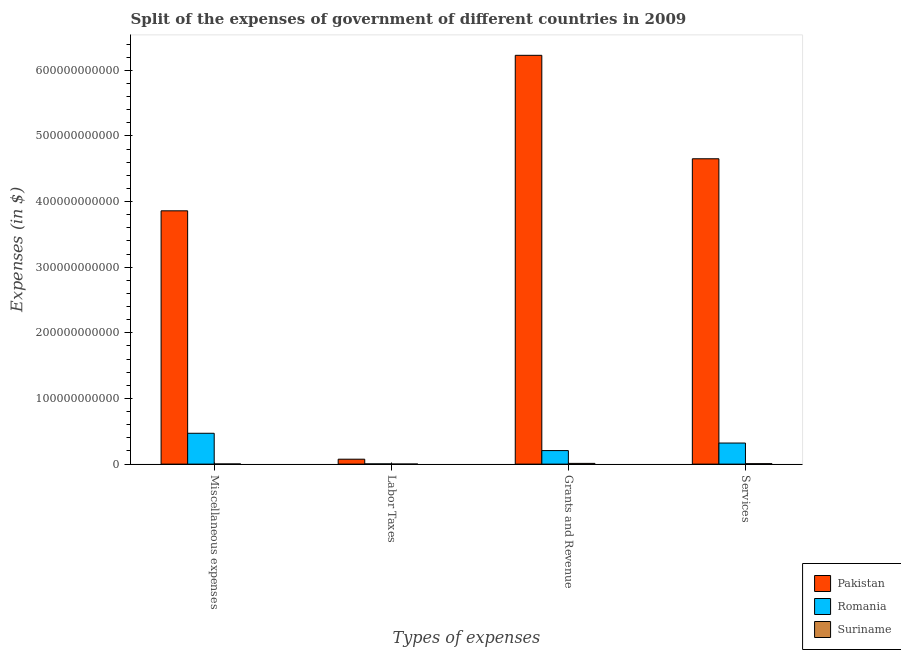How many different coloured bars are there?
Your answer should be very brief. 3. How many groups of bars are there?
Offer a terse response. 4. Are the number of bars on each tick of the X-axis equal?
Ensure brevity in your answer.  Yes. How many bars are there on the 4th tick from the left?
Provide a succinct answer. 3. How many bars are there on the 4th tick from the right?
Your response must be concise. 3. What is the label of the 1st group of bars from the left?
Make the answer very short. Miscellaneous expenses. What is the amount spent on miscellaneous expenses in Romania?
Give a very brief answer. 4.70e+1. Across all countries, what is the maximum amount spent on services?
Offer a terse response. 4.65e+11. Across all countries, what is the minimum amount spent on miscellaneous expenses?
Provide a succinct answer. 2.15e+08. In which country was the amount spent on labor taxes minimum?
Your answer should be compact. Suriname. What is the total amount spent on miscellaneous expenses in the graph?
Your response must be concise. 4.33e+11. What is the difference between the amount spent on services in Pakistan and that in Romania?
Offer a very short reply. 4.33e+11. What is the difference between the amount spent on labor taxes in Romania and the amount spent on miscellaneous expenses in Suriname?
Ensure brevity in your answer.  1.26e+08. What is the average amount spent on labor taxes per country?
Offer a terse response. 2.64e+09. What is the difference between the amount spent on labor taxes and amount spent on miscellaneous expenses in Suriname?
Your response must be concise. -1.29e+08. In how many countries, is the amount spent on services greater than 420000000000 $?
Make the answer very short. 1. What is the ratio of the amount spent on labor taxes in Pakistan to that in Suriname?
Provide a succinct answer. 87.54. Is the amount spent on labor taxes in Suriname less than that in Romania?
Provide a succinct answer. Yes. What is the difference between the highest and the second highest amount spent on labor taxes?
Offer a very short reply. 7.16e+09. What is the difference between the highest and the lowest amount spent on grants and revenue?
Your answer should be very brief. 6.22e+11. Is the sum of the amount spent on services in Suriname and Pakistan greater than the maximum amount spent on labor taxes across all countries?
Offer a terse response. Yes. Is it the case that in every country, the sum of the amount spent on miscellaneous expenses and amount spent on grants and revenue is greater than the sum of amount spent on labor taxes and amount spent on services?
Your answer should be compact. No. What does the 2nd bar from the left in Labor Taxes represents?
Your answer should be very brief. Romania. What does the 2nd bar from the right in Grants and Revenue represents?
Offer a very short reply. Romania. How many bars are there?
Your response must be concise. 12. Are all the bars in the graph horizontal?
Offer a very short reply. No. What is the difference between two consecutive major ticks on the Y-axis?
Give a very brief answer. 1.00e+11. Are the values on the major ticks of Y-axis written in scientific E-notation?
Offer a terse response. No. Does the graph contain any zero values?
Keep it short and to the point. No. What is the title of the graph?
Ensure brevity in your answer.  Split of the expenses of government of different countries in 2009. Does "Niger" appear as one of the legend labels in the graph?
Ensure brevity in your answer.  No. What is the label or title of the X-axis?
Make the answer very short. Types of expenses. What is the label or title of the Y-axis?
Provide a succinct answer. Expenses (in $). What is the Expenses (in $) of Pakistan in Miscellaneous expenses?
Provide a short and direct response. 3.86e+11. What is the Expenses (in $) in Romania in Miscellaneous expenses?
Make the answer very short. 4.70e+1. What is the Expenses (in $) in Suriname in Miscellaneous expenses?
Provide a succinct answer. 2.15e+08. What is the Expenses (in $) of Pakistan in Labor Taxes?
Make the answer very short. 7.50e+09. What is the Expenses (in $) of Romania in Labor Taxes?
Give a very brief answer. 3.41e+08. What is the Expenses (in $) in Suriname in Labor Taxes?
Keep it short and to the point. 8.57e+07. What is the Expenses (in $) of Pakistan in Grants and Revenue?
Make the answer very short. 6.23e+11. What is the Expenses (in $) of Romania in Grants and Revenue?
Your answer should be compact. 2.06e+1. What is the Expenses (in $) in Suriname in Grants and Revenue?
Keep it short and to the point. 1.11e+09. What is the Expenses (in $) of Pakistan in Services?
Keep it short and to the point. 4.65e+11. What is the Expenses (in $) in Romania in Services?
Give a very brief answer. 3.21e+1. What is the Expenses (in $) of Suriname in Services?
Your answer should be compact. 6.52e+08. Across all Types of expenses, what is the maximum Expenses (in $) of Pakistan?
Offer a terse response. 6.23e+11. Across all Types of expenses, what is the maximum Expenses (in $) of Romania?
Make the answer very short. 4.70e+1. Across all Types of expenses, what is the maximum Expenses (in $) of Suriname?
Your answer should be very brief. 1.11e+09. Across all Types of expenses, what is the minimum Expenses (in $) of Pakistan?
Your answer should be compact. 7.50e+09. Across all Types of expenses, what is the minimum Expenses (in $) in Romania?
Make the answer very short. 3.41e+08. Across all Types of expenses, what is the minimum Expenses (in $) of Suriname?
Your answer should be compact. 8.57e+07. What is the total Expenses (in $) of Pakistan in the graph?
Provide a short and direct response. 1.48e+12. What is the total Expenses (in $) of Romania in the graph?
Offer a very short reply. 1.00e+11. What is the total Expenses (in $) in Suriname in the graph?
Your answer should be compact. 2.07e+09. What is the difference between the Expenses (in $) in Pakistan in Miscellaneous expenses and that in Labor Taxes?
Ensure brevity in your answer.  3.78e+11. What is the difference between the Expenses (in $) in Romania in Miscellaneous expenses and that in Labor Taxes?
Offer a very short reply. 4.66e+1. What is the difference between the Expenses (in $) of Suriname in Miscellaneous expenses and that in Labor Taxes?
Your response must be concise. 1.29e+08. What is the difference between the Expenses (in $) of Pakistan in Miscellaneous expenses and that in Grants and Revenue?
Ensure brevity in your answer.  -2.37e+11. What is the difference between the Expenses (in $) of Romania in Miscellaneous expenses and that in Grants and Revenue?
Keep it short and to the point. 2.64e+1. What is the difference between the Expenses (in $) in Suriname in Miscellaneous expenses and that in Grants and Revenue?
Provide a short and direct response. -8.98e+08. What is the difference between the Expenses (in $) in Pakistan in Miscellaneous expenses and that in Services?
Offer a terse response. -7.93e+1. What is the difference between the Expenses (in $) in Romania in Miscellaneous expenses and that in Services?
Provide a short and direct response. 1.49e+1. What is the difference between the Expenses (in $) of Suriname in Miscellaneous expenses and that in Services?
Keep it short and to the point. -4.37e+08. What is the difference between the Expenses (in $) of Pakistan in Labor Taxes and that in Grants and Revenue?
Offer a very short reply. -6.15e+11. What is the difference between the Expenses (in $) of Romania in Labor Taxes and that in Grants and Revenue?
Provide a succinct answer. -2.03e+1. What is the difference between the Expenses (in $) in Suriname in Labor Taxes and that in Grants and Revenue?
Provide a short and direct response. -1.03e+09. What is the difference between the Expenses (in $) of Pakistan in Labor Taxes and that in Services?
Your answer should be compact. -4.58e+11. What is the difference between the Expenses (in $) of Romania in Labor Taxes and that in Services?
Provide a succinct answer. -3.18e+1. What is the difference between the Expenses (in $) in Suriname in Labor Taxes and that in Services?
Provide a succinct answer. -5.67e+08. What is the difference between the Expenses (in $) in Pakistan in Grants and Revenue and that in Services?
Provide a succinct answer. 1.58e+11. What is the difference between the Expenses (in $) of Romania in Grants and Revenue and that in Services?
Offer a very short reply. -1.15e+1. What is the difference between the Expenses (in $) in Suriname in Grants and Revenue and that in Services?
Your answer should be compact. 4.61e+08. What is the difference between the Expenses (in $) of Pakistan in Miscellaneous expenses and the Expenses (in $) of Romania in Labor Taxes?
Your answer should be compact. 3.86e+11. What is the difference between the Expenses (in $) of Pakistan in Miscellaneous expenses and the Expenses (in $) of Suriname in Labor Taxes?
Your response must be concise. 3.86e+11. What is the difference between the Expenses (in $) in Romania in Miscellaneous expenses and the Expenses (in $) in Suriname in Labor Taxes?
Offer a terse response. 4.69e+1. What is the difference between the Expenses (in $) in Pakistan in Miscellaneous expenses and the Expenses (in $) in Romania in Grants and Revenue?
Make the answer very short. 3.65e+11. What is the difference between the Expenses (in $) in Pakistan in Miscellaneous expenses and the Expenses (in $) in Suriname in Grants and Revenue?
Keep it short and to the point. 3.85e+11. What is the difference between the Expenses (in $) in Romania in Miscellaneous expenses and the Expenses (in $) in Suriname in Grants and Revenue?
Your response must be concise. 4.59e+1. What is the difference between the Expenses (in $) in Pakistan in Miscellaneous expenses and the Expenses (in $) in Romania in Services?
Offer a terse response. 3.54e+11. What is the difference between the Expenses (in $) of Pakistan in Miscellaneous expenses and the Expenses (in $) of Suriname in Services?
Keep it short and to the point. 3.85e+11. What is the difference between the Expenses (in $) of Romania in Miscellaneous expenses and the Expenses (in $) of Suriname in Services?
Your answer should be very brief. 4.63e+1. What is the difference between the Expenses (in $) of Pakistan in Labor Taxes and the Expenses (in $) of Romania in Grants and Revenue?
Your response must be concise. -1.31e+1. What is the difference between the Expenses (in $) in Pakistan in Labor Taxes and the Expenses (in $) in Suriname in Grants and Revenue?
Give a very brief answer. 6.39e+09. What is the difference between the Expenses (in $) in Romania in Labor Taxes and the Expenses (in $) in Suriname in Grants and Revenue?
Provide a succinct answer. -7.72e+08. What is the difference between the Expenses (in $) in Pakistan in Labor Taxes and the Expenses (in $) in Romania in Services?
Provide a succinct answer. -2.46e+1. What is the difference between the Expenses (in $) in Pakistan in Labor Taxes and the Expenses (in $) in Suriname in Services?
Make the answer very short. 6.85e+09. What is the difference between the Expenses (in $) of Romania in Labor Taxes and the Expenses (in $) of Suriname in Services?
Your answer should be very brief. -3.11e+08. What is the difference between the Expenses (in $) in Pakistan in Grants and Revenue and the Expenses (in $) in Romania in Services?
Ensure brevity in your answer.  5.91e+11. What is the difference between the Expenses (in $) of Pakistan in Grants and Revenue and the Expenses (in $) of Suriname in Services?
Provide a succinct answer. 6.22e+11. What is the difference between the Expenses (in $) of Romania in Grants and Revenue and the Expenses (in $) of Suriname in Services?
Ensure brevity in your answer.  2.00e+1. What is the average Expenses (in $) in Pakistan per Types of expenses?
Provide a short and direct response. 3.70e+11. What is the average Expenses (in $) in Romania per Types of expenses?
Provide a succinct answer. 2.50e+1. What is the average Expenses (in $) of Suriname per Types of expenses?
Offer a terse response. 5.16e+08. What is the difference between the Expenses (in $) of Pakistan and Expenses (in $) of Romania in Miscellaneous expenses?
Offer a terse response. 3.39e+11. What is the difference between the Expenses (in $) in Pakistan and Expenses (in $) in Suriname in Miscellaneous expenses?
Your answer should be very brief. 3.86e+11. What is the difference between the Expenses (in $) of Romania and Expenses (in $) of Suriname in Miscellaneous expenses?
Ensure brevity in your answer.  4.68e+1. What is the difference between the Expenses (in $) of Pakistan and Expenses (in $) of Romania in Labor Taxes?
Your response must be concise. 7.16e+09. What is the difference between the Expenses (in $) of Pakistan and Expenses (in $) of Suriname in Labor Taxes?
Your response must be concise. 7.42e+09. What is the difference between the Expenses (in $) of Romania and Expenses (in $) of Suriname in Labor Taxes?
Provide a succinct answer. 2.55e+08. What is the difference between the Expenses (in $) of Pakistan and Expenses (in $) of Romania in Grants and Revenue?
Your answer should be very brief. 6.02e+11. What is the difference between the Expenses (in $) in Pakistan and Expenses (in $) in Suriname in Grants and Revenue?
Provide a succinct answer. 6.22e+11. What is the difference between the Expenses (in $) in Romania and Expenses (in $) in Suriname in Grants and Revenue?
Offer a terse response. 1.95e+1. What is the difference between the Expenses (in $) of Pakistan and Expenses (in $) of Romania in Services?
Your response must be concise. 4.33e+11. What is the difference between the Expenses (in $) in Pakistan and Expenses (in $) in Suriname in Services?
Your answer should be very brief. 4.65e+11. What is the difference between the Expenses (in $) in Romania and Expenses (in $) in Suriname in Services?
Ensure brevity in your answer.  3.14e+1. What is the ratio of the Expenses (in $) of Pakistan in Miscellaneous expenses to that in Labor Taxes?
Your answer should be compact. 51.43. What is the ratio of the Expenses (in $) of Romania in Miscellaneous expenses to that in Labor Taxes?
Offer a terse response. 137.82. What is the ratio of the Expenses (in $) in Suriname in Miscellaneous expenses to that in Labor Taxes?
Offer a very short reply. 2.51. What is the ratio of the Expenses (in $) in Pakistan in Miscellaneous expenses to that in Grants and Revenue?
Make the answer very short. 0.62. What is the ratio of the Expenses (in $) in Romania in Miscellaneous expenses to that in Grants and Revenue?
Offer a very short reply. 2.28. What is the ratio of the Expenses (in $) of Suriname in Miscellaneous expenses to that in Grants and Revenue?
Provide a succinct answer. 0.19. What is the ratio of the Expenses (in $) in Pakistan in Miscellaneous expenses to that in Services?
Provide a succinct answer. 0.83. What is the ratio of the Expenses (in $) of Romania in Miscellaneous expenses to that in Services?
Your response must be concise. 1.46. What is the ratio of the Expenses (in $) of Suriname in Miscellaneous expenses to that in Services?
Offer a terse response. 0.33. What is the ratio of the Expenses (in $) in Pakistan in Labor Taxes to that in Grants and Revenue?
Your answer should be very brief. 0.01. What is the ratio of the Expenses (in $) of Romania in Labor Taxes to that in Grants and Revenue?
Your answer should be very brief. 0.02. What is the ratio of the Expenses (in $) of Suriname in Labor Taxes to that in Grants and Revenue?
Offer a terse response. 0.08. What is the ratio of the Expenses (in $) of Pakistan in Labor Taxes to that in Services?
Keep it short and to the point. 0.02. What is the ratio of the Expenses (in $) of Romania in Labor Taxes to that in Services?
Offer a very short reply. 0.01. What is the ratio of the Expenses (in $) of Suriname in Labor Taxes to that in Services?
Offer a terse response. 0.13. What is the ratio of the Expenses (in $) in Pakistan in Grants and Revenue to that in Services?
Give a very brief answer. 1.34. What is the ratio of the Expenses (in $) of Romania in Grants and Revenue to that in Services?
Offer a very short reply. 0.64. What is the ratio of the Expenses (in $) of Suriname in Grants and Revenue to that in Services?
Offer a very short reply. 1.71. What is the difference between the highest and the second highest Expenses (in $) in Pakistan?
Offer a very short reply. 1.58e+11. What is the difference between the highest and the second highest Expenses (in $) of Romania?
Give a very brief answer. 1.49e+1. What is the difference between the highest and the second highest Expenses (in $) in Suriname?
Offer a terse response. 4.61e+08. What is the difference between the highest and the lowest Expenses (in $) of Pakistan?
Your answer should be very brief. 6.15e+11. What is the difference between the highest and the lowest Expenses (in $) in Romania?
Keep it short and to the point. 4.66e+1. What is the difference between the highest and the lowest Expenses (in $) in Suriname?
Your answer should be compact. 1.03e+09. 